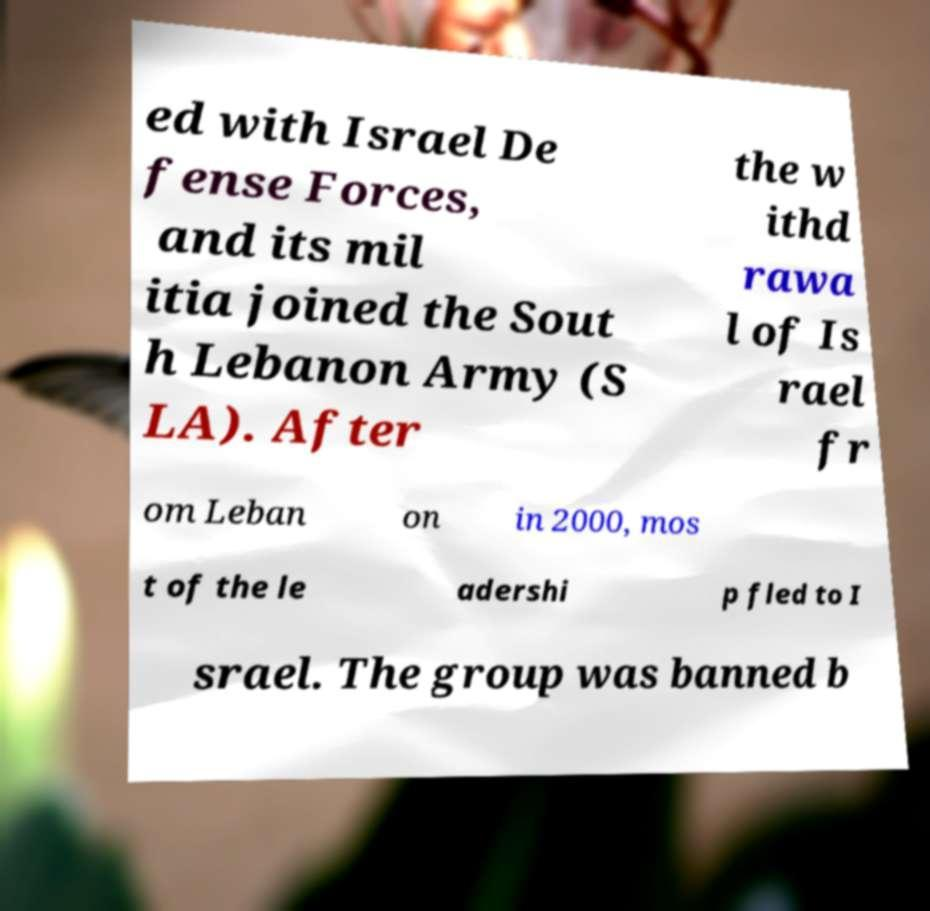Please identify and transcribe the text found in this image. ed with Israel De fense Forces, and its mil itia joined the Sout h Lebanon Army (S LA). After the w ithd rawa l of Is rael fr om Leban on in 2000, mos t of the le adershi p fled to I srael. The group was banned b 